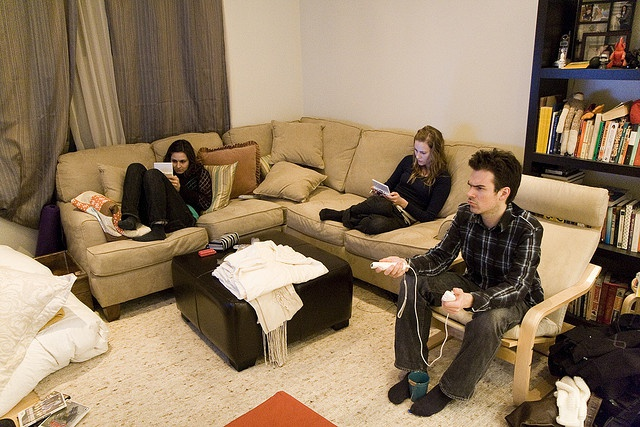Describe the objects in this image and their specific colors. I can see couch in gray, tan, black, and olive tones, people in gray and black tones, book in gray, black, tan, and olive tones, chair in gray and tan tones, and people in gray, black, and maroon tones in this image. 